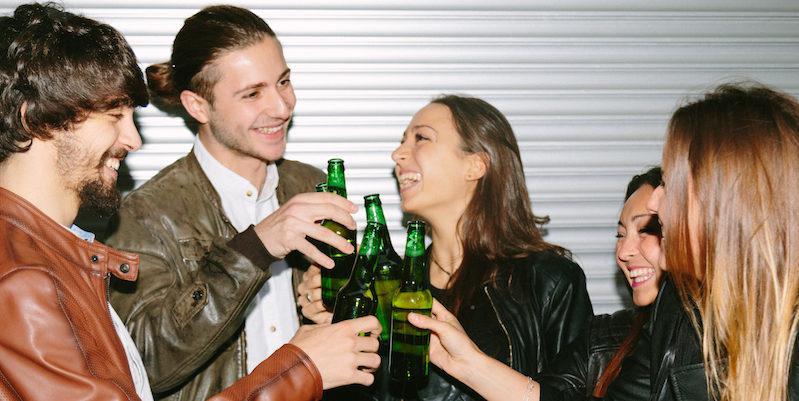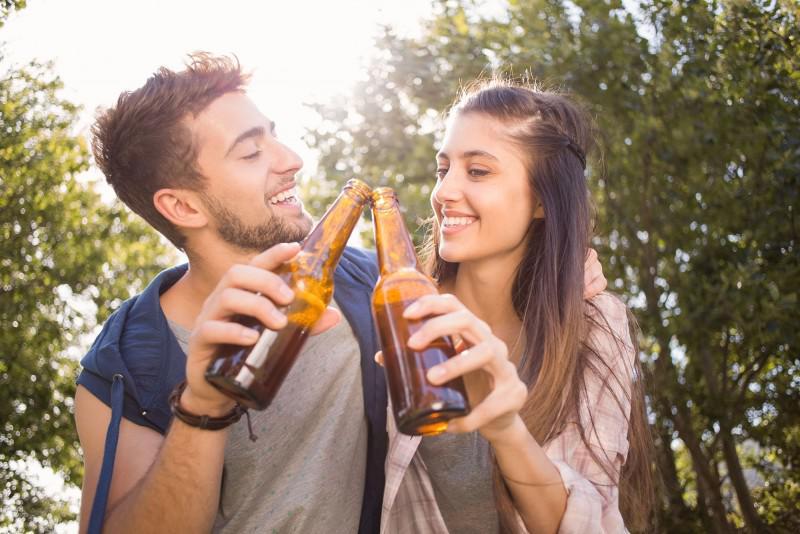The first image is the image on the left, the second image is the image on the right. Examine the images to the left and right. Is the description "In at least one image there are two people holding beer bottles." accurate? Answer yes or no. Yes. The first image is the image on the left, the second image is the image on the right. Given the left and right images, does the statement "In the right image, one person is lifting a glass bottle to drink, with their head tilted back." hold true? Answer yes or no. No. 